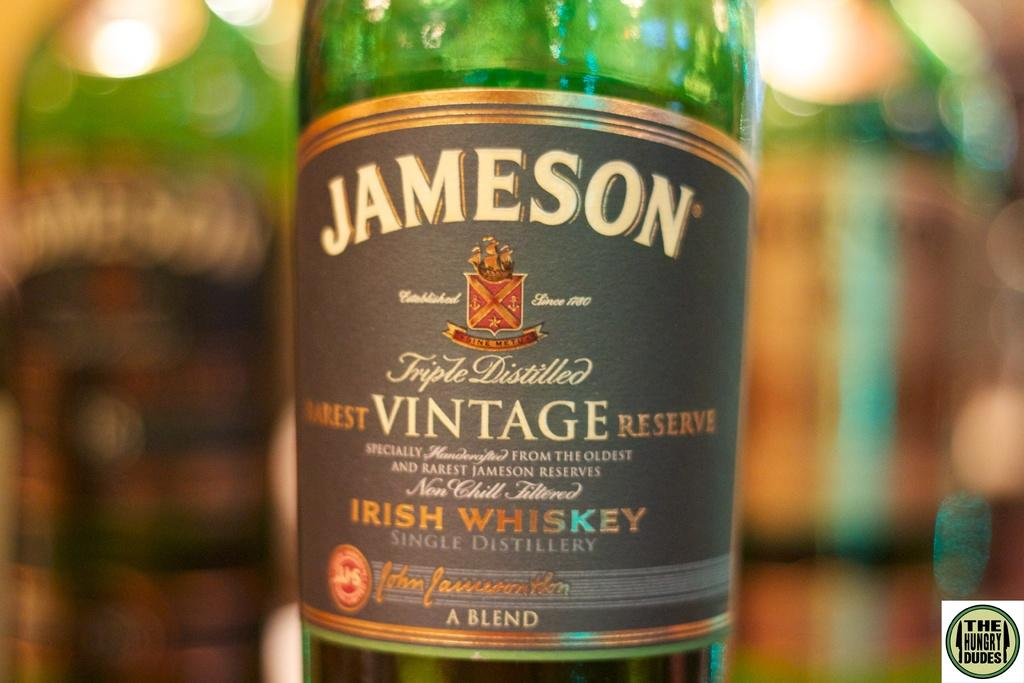Provide a one-sentence caption for the provided image. A bottle of Jameson vintage reserve says on the label that it is a blend. 